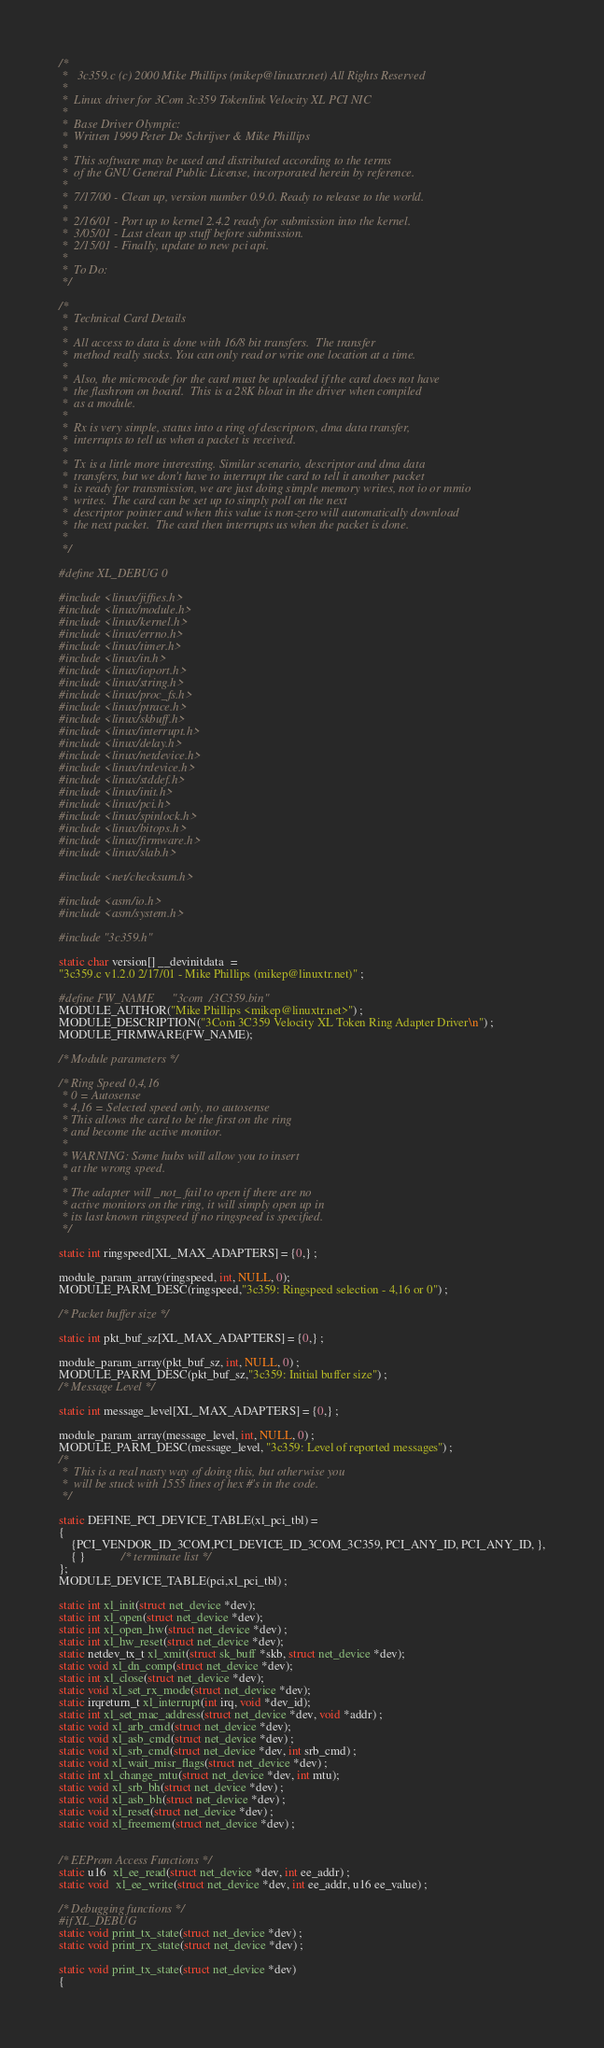Convert code to text. <code><loc_0><loc_0><loc_500><loc_500><_C_>/*
 *   3c359.c (c) 2000 Mike Phillips (mikep@linuxtr.net) All Rights Reserved
 *
 *  Linux driver for 3Com 3c359 Tokenlink Velocity XL PCI NIC
 *
 *  Base Driver Olympic:
 *	Written 1999 Peter De Schrijver & Mike Phillips
 *
 *  This software may be used and distributed according to the terms
 *  of the GNU General Public License, incorporated herein by reference.
 * 
 *  7/17/00 - Clean up, version number 0.9.0. Ready to release to the world.
 *
 *  2/16/01 - Port up to kernel 2.4.2 ready for submission into the kernel.
 *  3/05/01 - Last clean up stuff before submission.
 *  2/15/01 - Finally, update to new pci api. 
 *
 *  To Do:
 */

/* 
 *	Technical Card Details
 *
 *  All access to data is done with 16/8 bit transfers.  The transfer
 *  method really sucks. You can only read or write one location at a time.
 *
 *  Also, the microcode for the card must be uploaded if the card does not have
 *  the flashrom on board.  This is a 28K bloat in the driver when compiled
 *  as a module.
 *
 *  Rx is very simple, status into a ring of descriptors, dma data transfer,
 *  interrupts to tell us when a packet is received.
 *
 *  Tx is a little more interesting. Similar scenario, descriptor and dma data
 *  transfers, but we don't have to interrupt the card to tell it another packet
 *  is ready for transmission, we are just doing simple memory writes, not io or mmio
 *  writes.  The card can be set up to simply poll on the next
 *  descriptor pointer and when this value is non-zero will automatically download
 *  the next packet.  The card then interrupts us when the packet is done.
 *
 */

#define XL_DEBUG 0

#include <linux/jiffies.h>
#include <linux/module.h>
#include <linux/kernel.h>
#include <linux/errno.h>
#include <linux/timer.h>
#include <linux/in.h>
#include <linux/ioport.h>
#include <linux/string.h>
#include <linux/proc_fs.h>
#include <linux/ptrace.h>
#include <linux/skbuff.h>
#include <linux/interrupt.h>
#include <linux/delay.h>
#include <linux/netdevice.h>
#include <linux/trdevice.h>
#include <linux/stddef.h>
#include <linux/init.h>
#include <linux/pci.h>
#include <linux/spinlock.h>
#include <linux/bitops.h>
#include <linux/firmware.h>
#include <linux/slab.h>

#include <net/checksum.h>

#include <asm/io.h>
#include <asm/system.h>

#include "3c359.h"

static char version[] __devinitdata  = 
"3c359.c v1.2.0 2/17/01 - Mike Phillips (mikep@linuxtr.net)" ; 

#define FW_NAME		"3com/3C359.bin"
MODULE_AUTHOR("Mike Phillips <mikep@linuxtr.net>") ; 
MODULE_DESCRIPTION("3Com 3C359 Velocity XL Token Ring Adapter Driver\n") ;
MODULE_FIRMWARE(FW_NAME);

/* Module parameters */

/* Ring Speed 0,4,16 
 * 0 = Autosense   
 * 4,16 = Selected speed only, no autosense
 * This allows the card to be the first on the ring
 * and become the active monitor.
 *
 * WARNING: Some hubs will allow you to insert
 * at the wrong speed.
 * 
 * The adapter will _not_ fail to open if there are no
 * active monitors on the ring, it will simply open up in 
 * its last known ringspeed if no ringspeed is specified.
 */

static int ringspeed[XL_MAX_ADAPTERS] = {0,} ;

module_param_array(ringspeed, int, NULL, 0);
MODULE_PARM_DESC(ringspeed,"3c359: Ringspeed selection - 4,16 or 0") ;

/* Packet buffer size */

static int pkt_buf_sz[XL_MAX_ADAPTERS] = {0,} ;
 
module_param_array(pkt_buf_sz, int, NULL, 0) ;
MODULE_PARM_DESC(pkt_buf_sz,"3c359: Initial buffer size") ;
/* Message Level */

static int message_level[XL_MAX_ADAPTERS] = {0,} ;

module_param_array(message_level, int, NULL, 0) ;
MODULE_PARM_DESC(message_level, "3c359: Level of reported messages") ;
/* 
 *	This is a real nasty way of doing this, but otherwise you
 *	will be stuck with 1555 lines of hex #'s in the code.
 */

static DEFINE_PCI_DEVICE_TABLE(xl_pci_tbl) =
{
	{PCI_VENDOR_ID_3COM,PCI_DEVICE_ID_3COM_3C359, PCI_ANY_ID, PCI_ANY_ID, },
	{ }			/* terminate list */
};
MODULE_DEVICE_TABLE(pci,xl_pci_tbl) ; 

static int xl_init(struct net_device *dev);
static int xl_open(struct net_device *dev);
static int xl_open_hw(struct net_device *dev) ;  
static int xl_hw_reset(struct net_device *dev); 
static netdev_tx_t xl_xmit(struct sk_buff *skb, struct net_device *dev);
static void xl_dn_comp(struct net_device *dev); 
static int xl_close(struct net_device *dev);
static void xl_set_rx_mode(struct net_device *dev);
static irqreturn_t xl_interrupt(int irq, void *dev_id);
static int xl_set_mac_address(struct net_device *dev, void *addr) ; 
static void xl_arb_cmd(struct net_device *dev);
static void xl_asb_cmd(struct net_device *dev) ; 
static void xl_srb_cmd(struct net_device *dev, int srb_cmd) ; 
static void xl_wait_misr_flags(struct net_device *dev) ; 
static int xl_change_mtu(struct net_device *dev, int mtu);
static void xl_srb_bh(struct net_device *dev) ; 
static void xl_asb_bh(struct net_device *dev) ; 
static void xl_reset(struct net_device *dev) ;  
static void xl_freemem(struct net_device *dev) ;  


/* EEProm Access Functions */
static u16  xl_ee_read(struct net_device *dev, int ee_addr) ; 
static void  xl_ee_write(struct net_device *dev, int ee_addr, u16 ee_value) ; 

/* Debugging functions */
#if XL_DEBUG
static void print_tx_state(struct net_device *dev) ; 
static void print_rx_state(struct net_device *dev) ; 

static void print_tx_state(struct net_device *dev)
{
</code> 